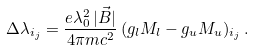<formula> <loc_0><loc_0><loc_500><loc_500>\Delta \lambda _ { i _ { j } } = \frac { e \lambda _ { 0 } ^ { 2 } \, | \vec { B } | } { 4 \pi m c ^ { 2 } } \, ( g _ { l } M _ { l } - g _ { u } M _ { u } ) _ { i _ { j } } \, .</formula> 